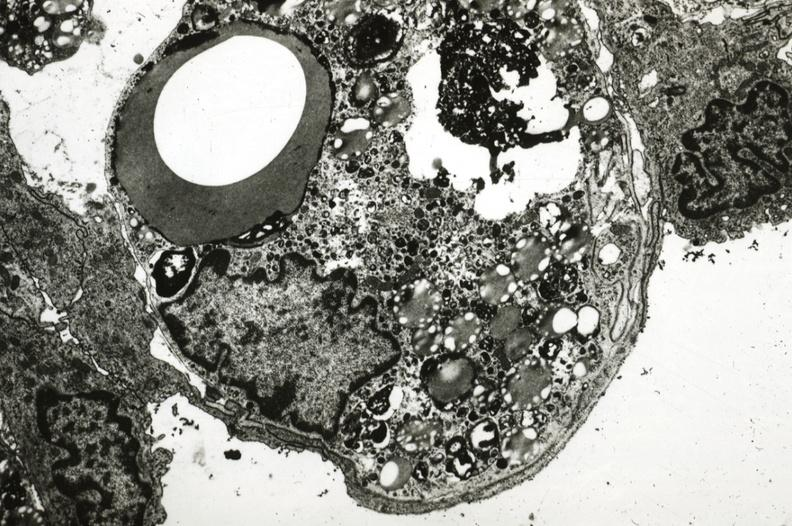what is present?
Answer the question using a single word or phrase. Cardiovascular 